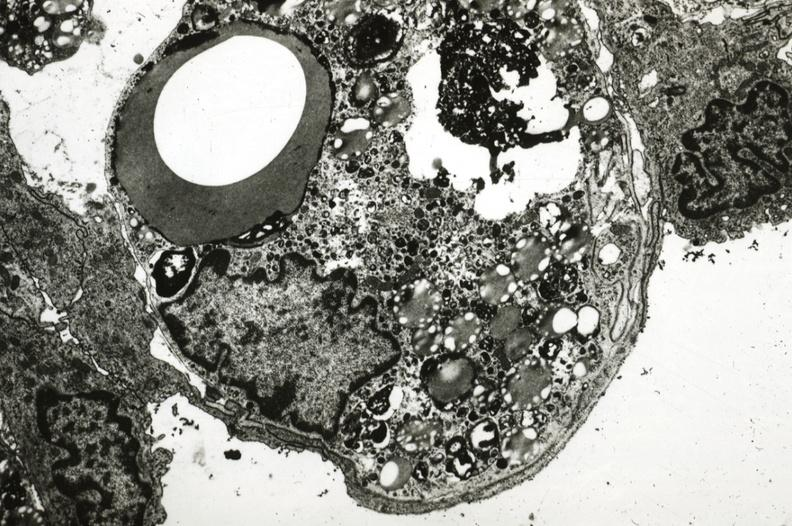what is present?
Answer the question using a single word or phrase. Cardiovascular 